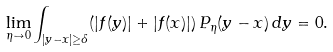Convert formula to latex. <formula><loc_0><loc_0><loc_500><loc_500>\lim _ { \eta \to 0 } \int _ { | y - x | \geq \delta } ( | f ( y ) | + | f ( x ) | ) \, P _ { \eta } ( y - x ) \, d y = 0 .</formula> 